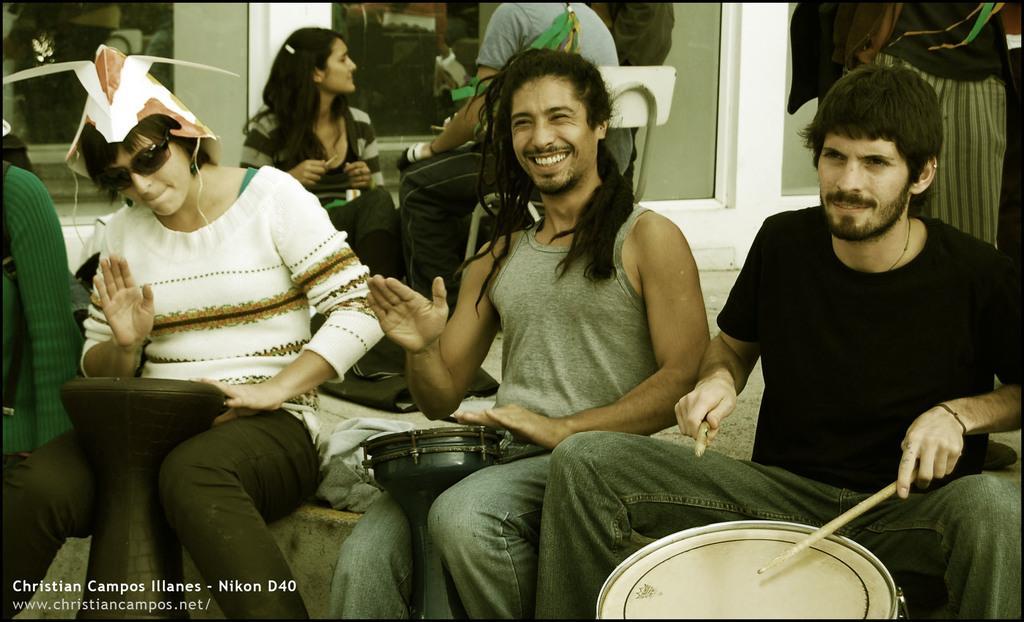In one or two sentences, can you explain what this image depicts? In the picture there are four people sitting. First person is playing the drums and second person is smiling and third woman is playing some action. In the background we can find another woman and person sitting on a chairs. 